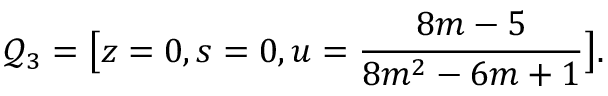<formula> <loc_0><loc_0><loc_500><loc_500>\mathcal { Q } _ { 3 } = \left [ z = 0 , s = 0 , u = \frac { 8 m - 5 } { 8 m ^ { 2 } - 6 m + 1 } \right ] .</formula> 